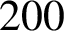<formula> <loc_0><loc_0><loc_500><loc_500>2 0 0</formula> 